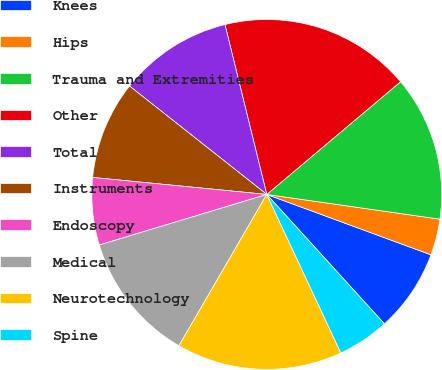Convert chart. <chart><loc_0><loc_0><loc_500><loc_500><pie_chart><fcel>Knees<fcel>Hips<fcel>Trauma and Extremities<fcel>Other<fcel>Total<fcel>Instruments<fcel>Endoscopy<fcel>Medical<fcel>Neurotechnology<fcel>Spine<nl><fcel>7.65%<fcel>3.35%<fcel>13.4%<fcel>17.7%<fcel>10.52%<fcel>9.09%<fcel>6.22%<fcel>11.96%<fcel>15.33%<fcel>4.78%<nl></chart> 